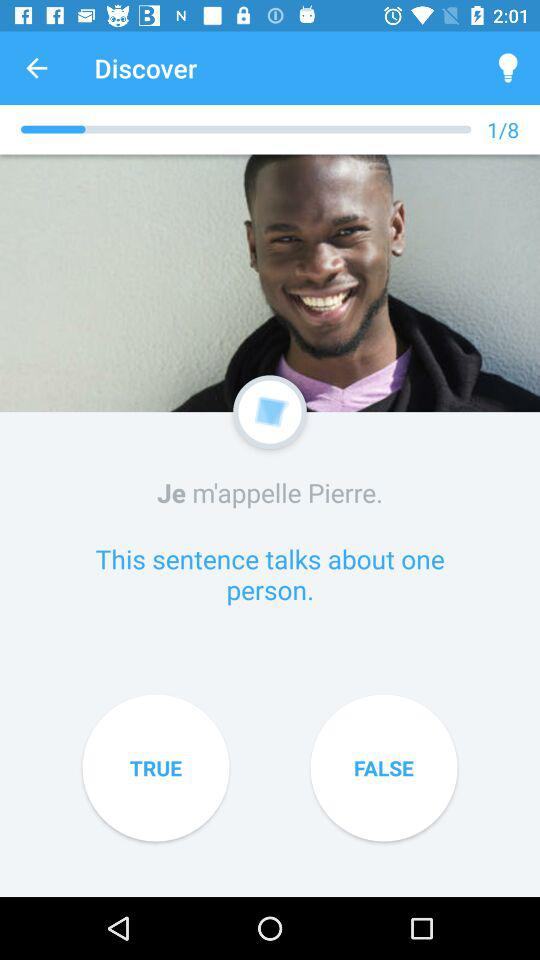How many sentences are on the screen?
Answer the question using a single word or phrase. 2 